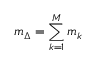<formula> <loc_0><loc_0><loc_500><loc_500>m _ { \Delta } = \sum _ { k = 1 } ^ { M } m _ { k }</formula> 